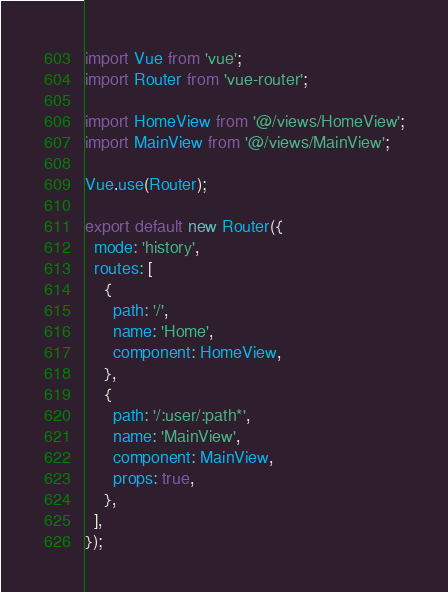Convert code to text. <code><loc_0><loc_0><loc_500><loc_500><_JavaScript_>import Vue from 'vue';
import Router from 'vue-router';

import HomeView from '@/views/HomeView';
import MainView from '@/views/MainView';

Vue.use(Router);

export default new Router({
  mode: 'history',
  routes: [
    {
      path: '/',
      name: 'Home',
      component: HomeView,
    },
    {
      path: '/:user/:path*',
      name: 'MainView',
      component: MainView,
      props: true,
    },
  ],
});
</code> 